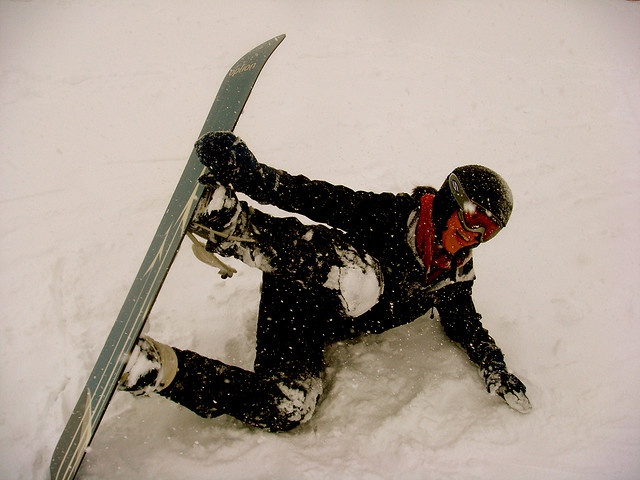Describe the objects in this image and their specific colors. I can see people in darkgray, black, maroon, olive, and tan tones and snowboard in darkgray, gray, tan, and darkgreen tones in this image. 